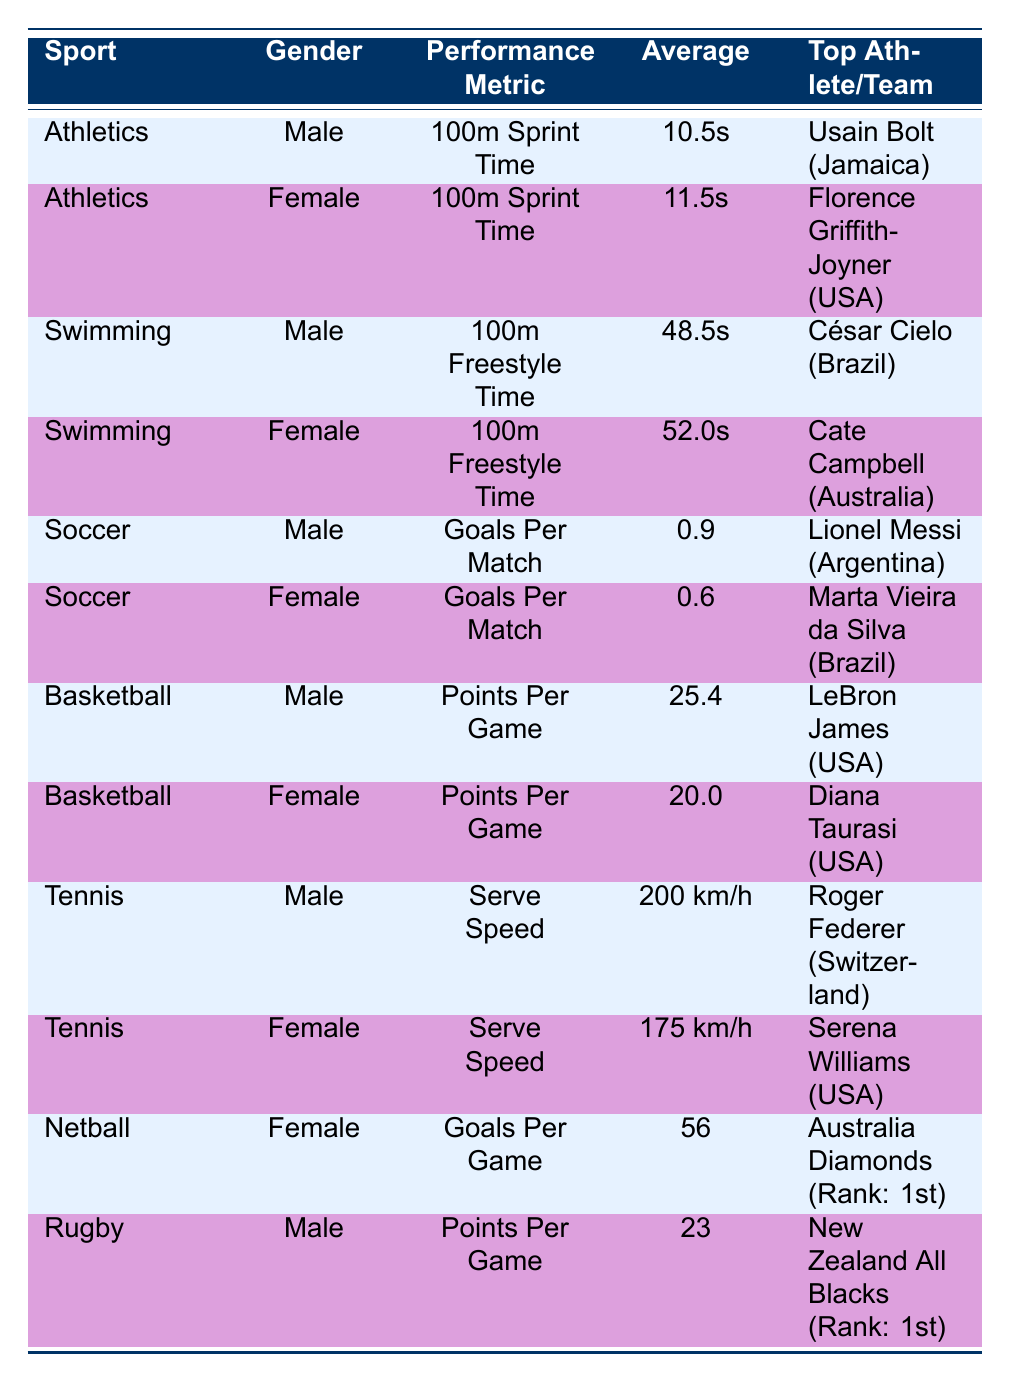What is the average time for the 100m Sprint for female athletes? The average time for the 100m Sprint for female athletes is given in the table as 11.5 seconds. This value is specifically mentioned under the female category for Athletics.
Answer: 11.5 seconds Who is the top male athlete in Swimming? The table provides the name of the top male athlete in Swimming as César Cielo, who is from Brazil. This information is directly listed under the Swimming section for male athletes.
Answer: César Cielo What is the difference in average points per game between male and female basketball players? The average points per game for male basketball players is 25.4, while for female basketball players it is 20.0. To find the difference, we subtract: 25.4 - 20.0 = 5.4.
Answer: 5.4 Is the average goals per match higher for male soccer players than for female soccer players? The average goals per match for male soccer players is 0.9, while for female soccer players it is 0.6. Since 0.9 is greater than 0.6, it confirms that male soccer players have a higher average.
Answer: Yes Which female athlete has the fastest personal best time in the 100m Sprint? The table shows that Florence Griffith-Joyner has a personal best time of 10.49 seconds in the 100m Sprint, which is the fastest time listed for female athletes in Athletics.
Answer: Florence Griffith-Joyner 